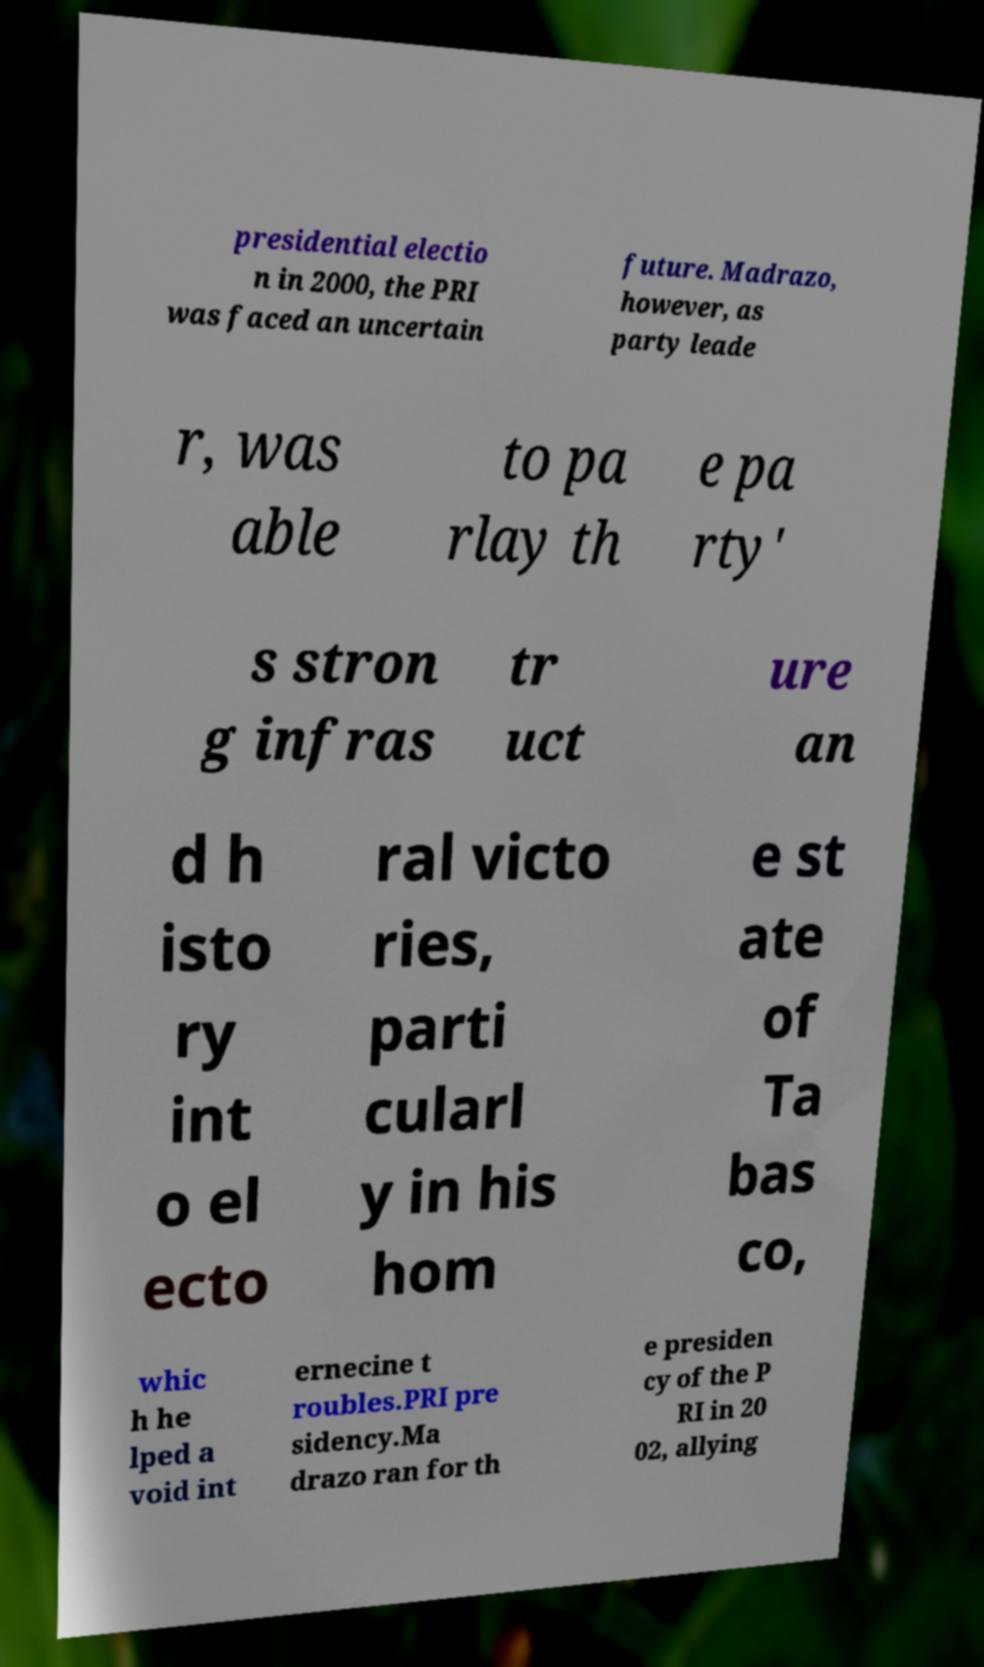Could you assist in decoding the text presented in this image and type it out clearly? presidential electio n in 2000, the PRI was faced an uncertain future. Madrazo, however, as party leade r, was able to pa rlay th e pa rty' s stron g infras tr uct ure an d h isto ry int o el ecto ral victo ries, parti cularl y in his hom e st ate of Ta bas co, whic h he lped a void int ernecine t roubles.PRI pre sidency.Ma drazo ran for th e presiden cy of the P RI in 20 02, allying 